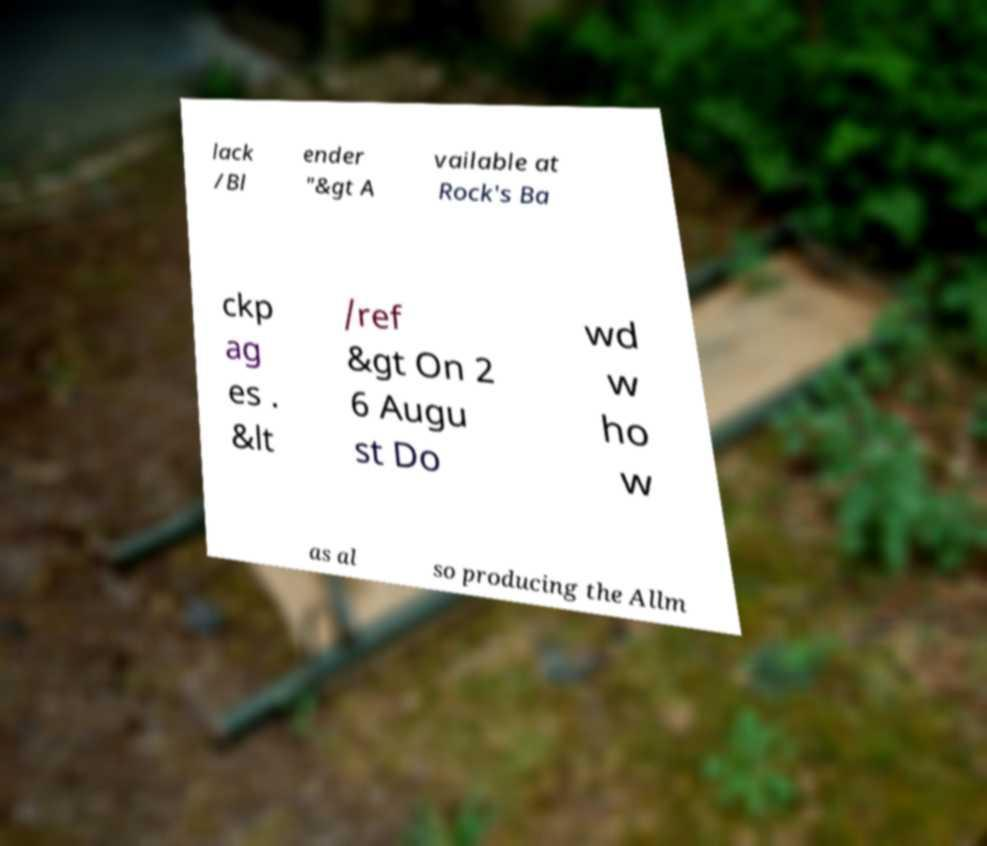For documentation purposes, I need the text within this image transcribed. Could you provide that? lack /Bl ender "&gt A vailable at Rock's Ba ckp ag es . &lt /ref &gt On 2 6 Augu st Do wd w ho w as al so producing the Allm 